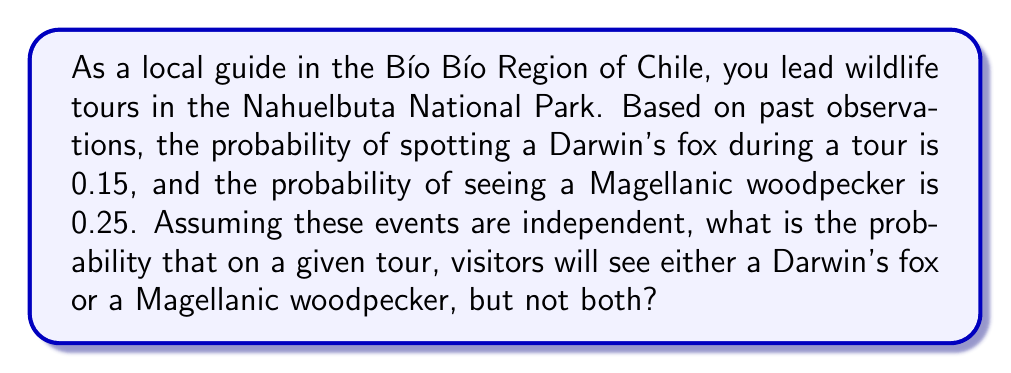Can you answer this question? To solve this problem, we'll use the concept of mutually exclusive events and the addition rule of probability.

Let's define our events:
A = spotting a Darwin's fox
B = seeing a Magellanic woodpecker

Given:
P(A) = 0.15
P(B) = 0.25

We want to find P(A or B, but not both). This can be expressed as:
P(A or B, but not both) = P(A) + P(B) - 2P(A and B)

Since the events are independent, we can calculate P(A and B):
P(A and B) = P(A) × P(B) = 0.15 × 0.25 = 0.0375

Now, let's substitute these values into our equation:

$$\begin{align}
P(\text{A or B, but not both}) &= P(A) + P(B) - 2P(A \text{ and } B) \\
&= 0.15 + 0.25 - 2(0.0375) \\
&= 0.40 - 0.075 \\
&= 0.325
\end{align}$$

Therefore, the probability of seeing either a Darwin's fox or a Magellanic woodpecker, but not both, during a tour is 0.325 or 32.5%.
Answer: 0.325 or 32.5% 